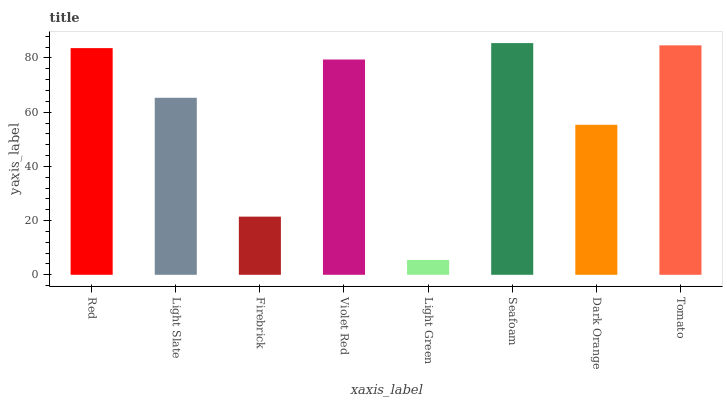Is Light Slate the minimum?
Answer yes or no. No. Is Light Slate the maximum?
Answer yes or no. No. Is Red greater than Light Slate?
Answer yes or no. Yes. Is Light Slate less than Red?
Answer yes or no. Yes. Is Light Slate greater than Red?
Answer yes or no. No. Is Red less than Light Slate?
Answer yes or no. No. Is Violet Red the high median?
Answer yes or no. Yes. Is Light Slate the low median?
Answer yes or no. Yes. Is Firebrick the high median?
Answer yes or no. No. Is Firebrick the low median?
Answer yes or no. No. 